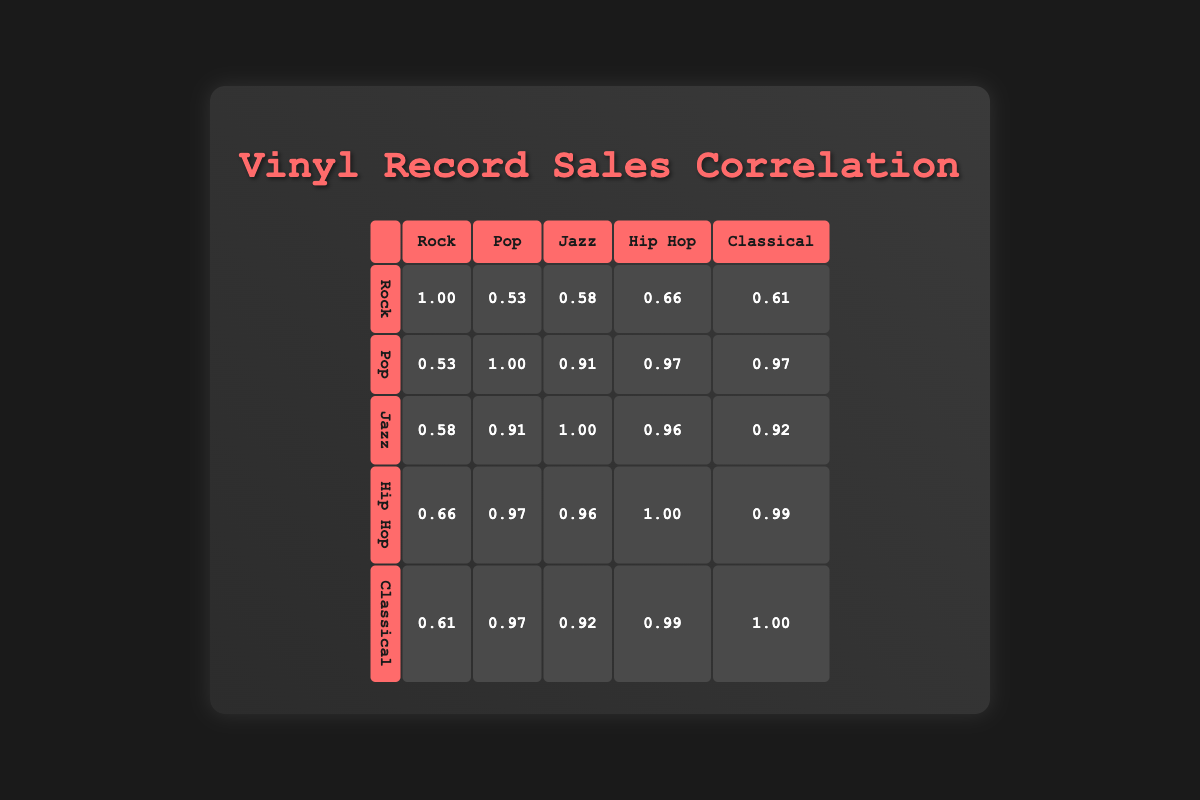What is the correlation between rock and pop sales? The table shows the correlation value for rock and pop in their intersection cell, which is 0.73. This indicates a moderate positive correlation between the two genres, meaning that as one increases, the other tends to increase as well.
Answer: 0.73 Which genre had the highest sales in 2023? By examining the last row for the year 2023, rock had the highest sales of 1,000,000 compared to the other genres.
Answer: Rock What is the average sales for jazz over the years listed? To find the average sales for jazz, add all the sales figures together: 200000 + 250000 + 300000 + 280000 + 320000 + 350000 = 1700000. Then divide by the number of years (6): 1700000 / 6 = 283333.33, which can be rounded to 283333.
Answer: 283333 Does hip hop have a higher correlation with pop than with classical? The correlation values show that hip hop and pop have a correlation of 0.95, while hip hop and classical have a correlation of 0.97. Since 0.97 is greater than 0.95, hip hop has a higher correlation with classical than with pop.
Answer: No What is the difference in sales between the highest and lowest selling genre in 2021? To find this, first identify the sales in 2021: rock - 850000, pop - 900000, jazz - 280000, hip hop - 220000, classical - 180000. The highest is pop with 900000 and the lowest is classical with 180000. The difference is calculated as 900000 - 180000 = 720000.
Answer: 720000 Is the correlation between jazz and hip hop stronger than the correlation between rock and classical? Looking at the table, the correlation between jazz and hip hop is 0.98 while the correlation between rock and classical is 0.94. Since 0.98 is greater than 0.94, jazz and hip hop have a stronger correlation than rock and classical.
Answer: Yes What year saw the lowest total sales across all genres? To find this, calculate the total sales for each year: 
- 2018: 800000 + 600000 + 200000 + 150000 + 100000 = 1850000 
- 2019: 900000 + 700000 + 250000 + 180000 + 120000 = 2150000 
- 2020: 750000 + 800000 + 300000 + 200000 + 150000 = 2200000 
- 2021: 850000 + 900000 + 280000 + 220000 + 180000 = 2430000 
- 2022: 950000 + 850000 + 320000 + 230000 + 190000 = 2540000 
- 2023: 1000000 + 950000 + 350000 + 250000 + 200000 = 2850000. So, 2018 has the lowest total sales.
Answer: 2018 What is the correlation between pop and jazz sales? The correlation value for pop and jazz can be found in their intersection cell, which is 0.92. This indicates a very strong positive correlation, suggesting that increases in sales for one genre are closely tied to increases in sales for the other.
Answer: 0.92 In which year did classical sales show the highest increase from the previous year? To find the highest increase in classical sales, compare the sales year-on-year: 
- 2019 - 2018 = 120000 - 100000 = 20000
- 2020 - 2019 = 150000 - 120000 = 30000
- 2021 - 2020 = 180000 - 150000 = 30000
- 2022 - 2021 = 190000 - 180000 = 10000
- 2023 - 2022 = 200000 - 190000 = 10000. The highest increase was in 2020.
Answer: 2020 